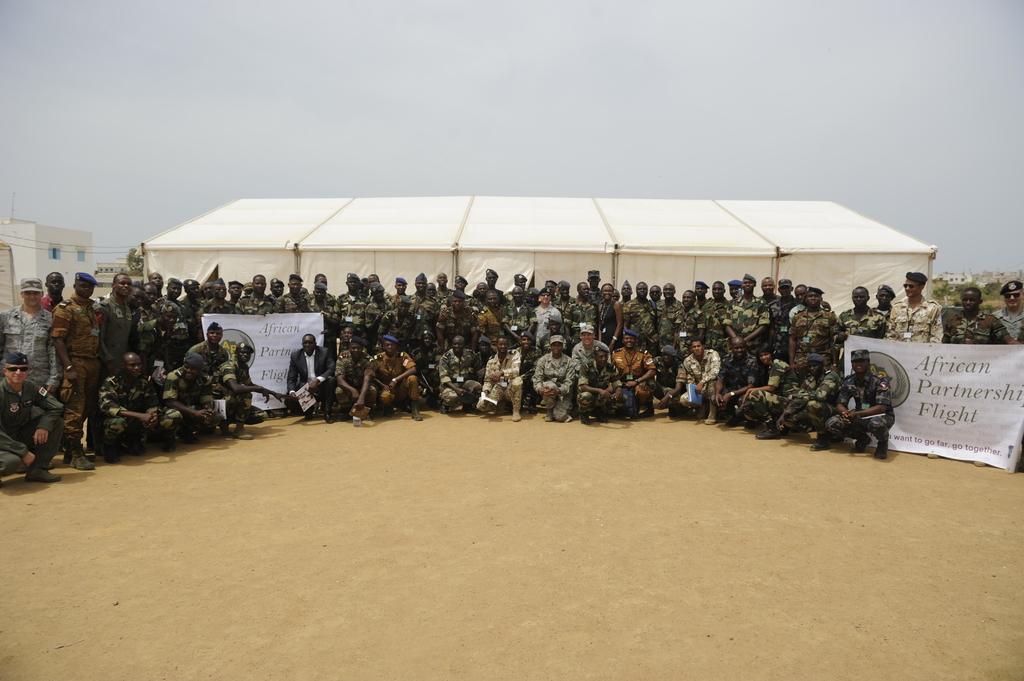Could you give a brief overview of what you see in this image? In the image there are a lot of people in the foreground, all of them are posing for the photo and there are two banners in front of them and in the background there is a tent, on the left side there is a building. 